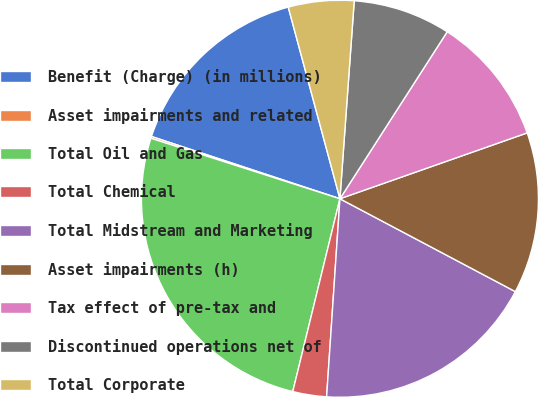<chart> <loc_0><loc_0><loc_500><loc_500><pie_chart><fcel>Benefit (Charge) (in millions)<fcel>Asset impairments and related<fcel>Total Oil and Gas<fcel>Total Chemical<fcel>Total Midstream and Marketing<fcel>Asset impairments (h)<fcel>Tax effect of pre-tax and<fcel>Discontinued operations net of<fcel>Total Corporate<nl><fcel>15.73%<fcel>0.15%<fcel>26.11%<fcel>2.75%<fcel>18.32%<fcel>13.13%<fcel>10.53%<fcel>7.94%<fcel>5.34%<nl></chart> 